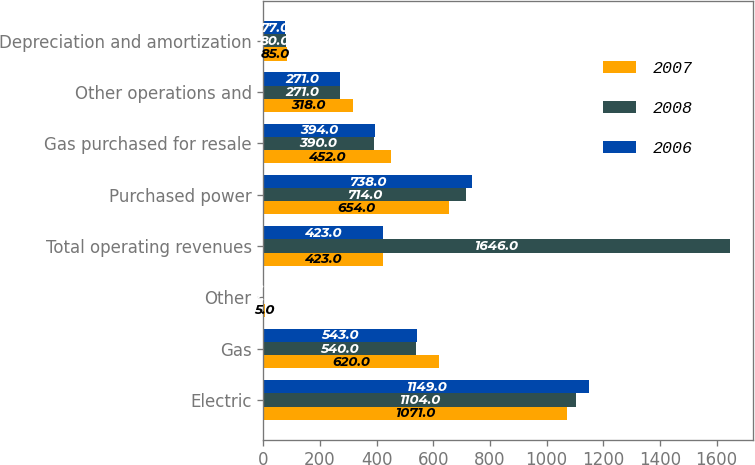<chart> <loc_0><loc_0><loc_500><loc_500><stacked_bar_chart><ecel><fcel>Electric<fcel>Gas<fcel>Other<fcel>Total operating revenues<fcel>Purchased power<fcel>Gas purchased for resale<fcel>Other operations and<fcel>Depreciation and amortization<nl><fcel>2007<fcel>1071<fcel>620<fcel>5<fcel>423<fcel>654<fcel>452<fcel>318<fcel>85<nl><fcel>2008<fcel>1104<fcel>540<fcel>2<fcel>1646<fcel>714<fcel>390<fcel>271<fcel>80<nl><fcel>2006<fcel>1149<fcel>543<fcel>2<fcel>423<fcel>738<fcel>394<fcel>271<fcel>77<nl></chart> 